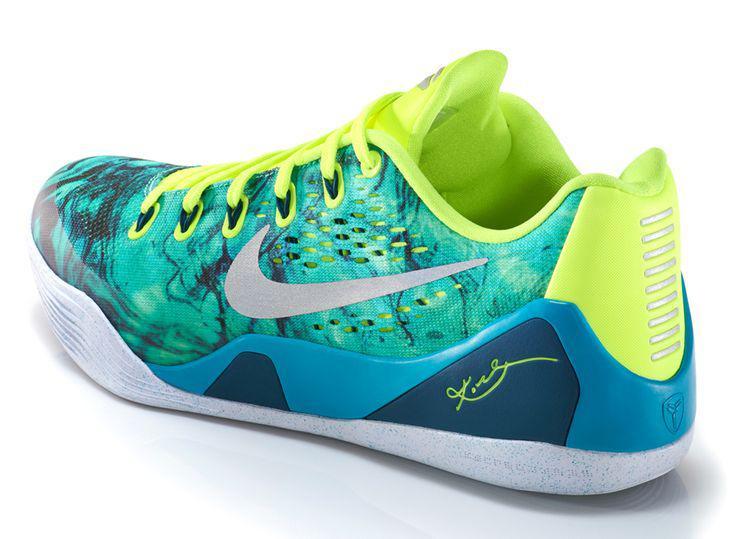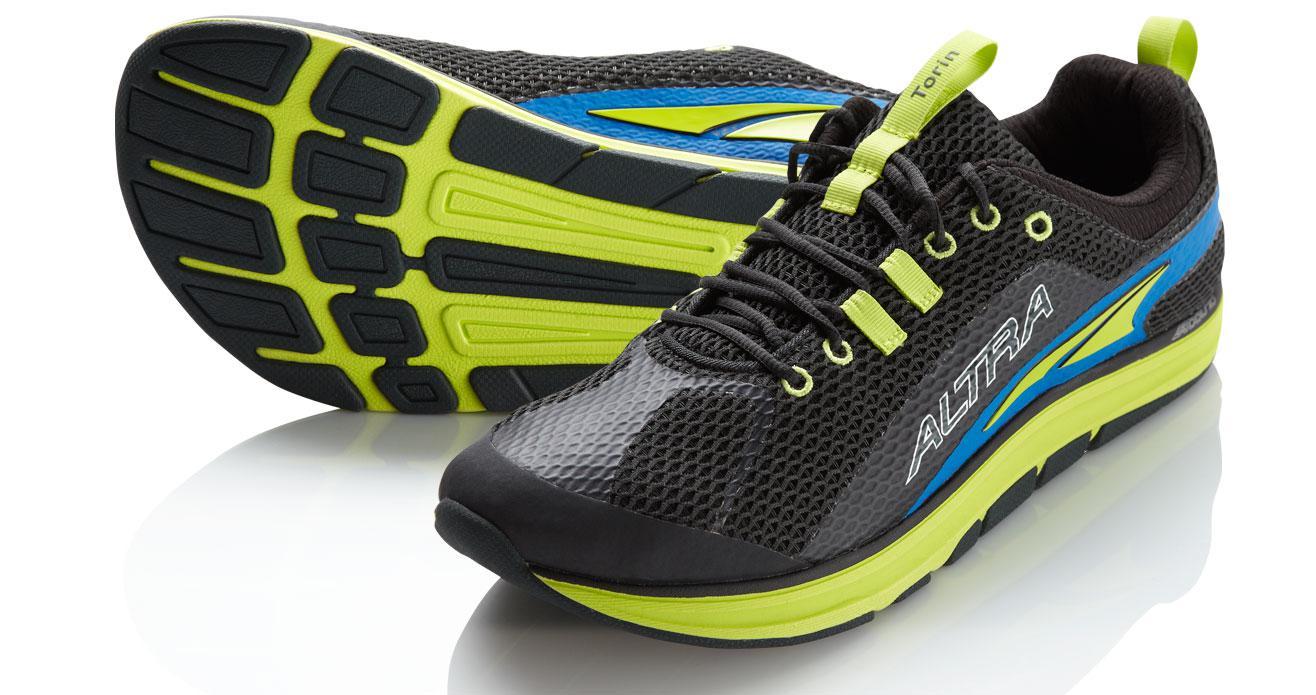The first image is the image on the left, the second image is the image on the right. For the images displayed, is the sentence "A pair of shoes are on the right side." factually correct? Answer yes or no. Yes. 